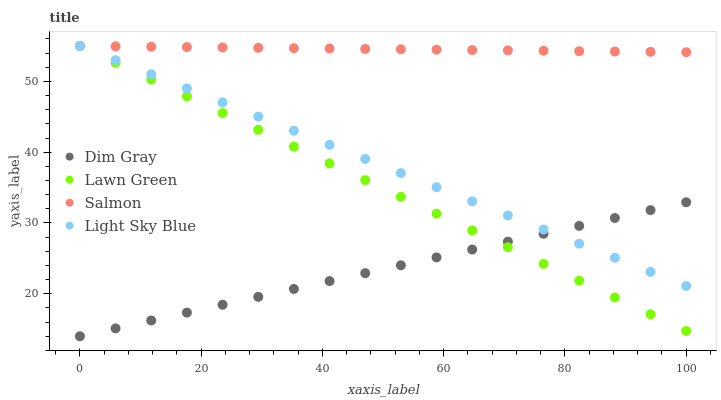Does Dim Gray have the minimum area under the curve?
Answer yes or no. Yes. Does Salmon have the maximum area under the curve?
Answer yes or no. Yes. Does Salmon have the minimum area under the curve?
Answer yes or no. No. Does Dim Gray have the maximum area under the curve?
Answer yes or no. No. Is Lawn Green the smoothest?
Answer yes or no. Yes. Is Light Sky Blue the roughest?
Answer yes or no. Yes. Is Dim Gray the smoothest?
Answer yes or no. No. Is Dim Gray the roughest?
Answer yes or no. No. Does Dim Gray have the lowest value?
Answer yes or no. Yes. Does Salmon have the lowest value?
Answer yes or no. No. Does Light Sky Blue have the highest value?
Answer yes or no. Yes. Does Dim Gray have the highest value?
Answer yes or no. No. Is Dim Gray less than Salmon?
Answer yes or no. Yes. Is Salmon greater than Dim Gray?
Answer yes or no. Yes. Does Lawn Green intersect Dim Gray?
Answer yes or no. Yes. Is Lawn Green less than Dim Gray?
Answer yes or no. No. Is Lawn Green greater than Dim Gray?
Answer yes or no. No. Does Dim Gray intersect Salmon?
Answer yes or no. No. 